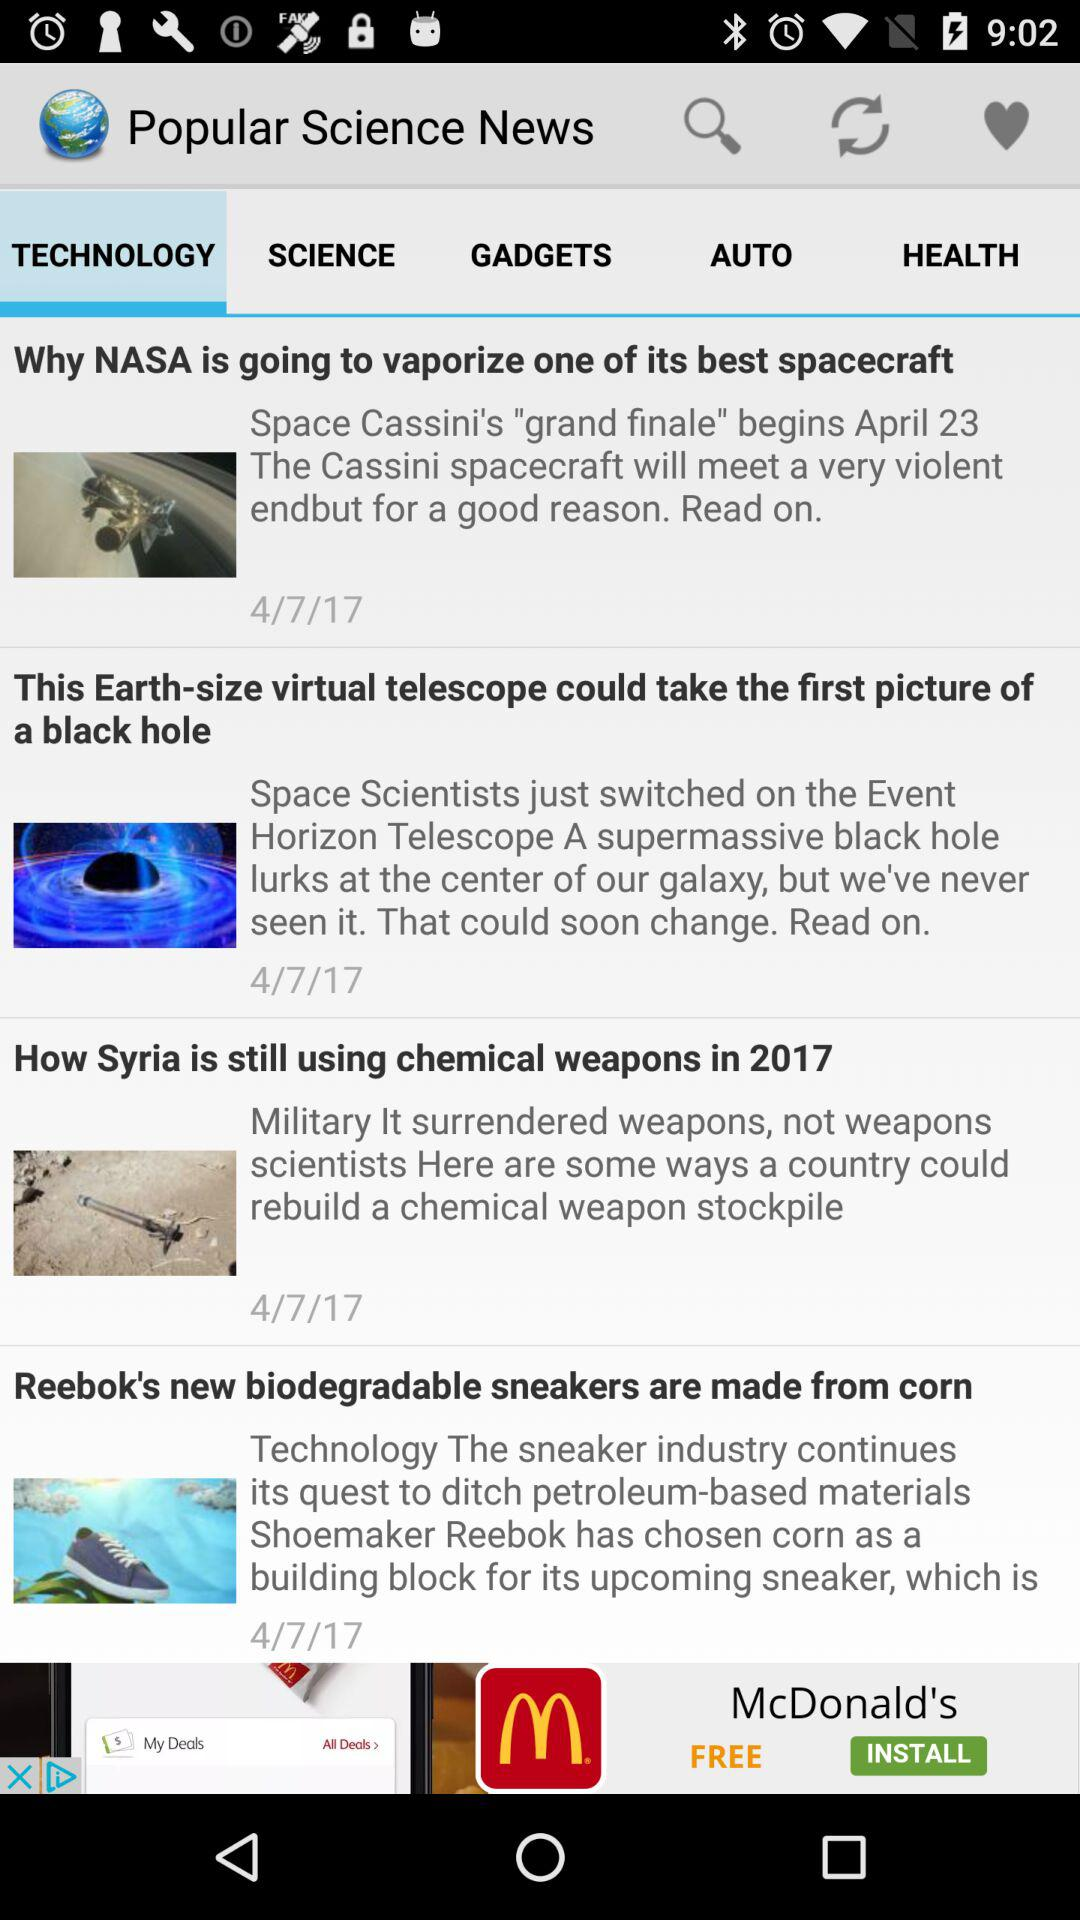What popular science news is displayed on the screen? The displayed popular science news is about "TECHNOLOGY". 